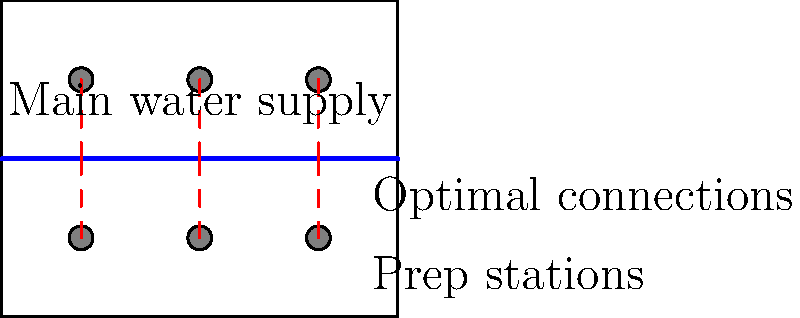As a celebrity chef planning to launch a new product line, you're designing a restaurant kitchen with six preparation stations. Given the layout shown, what is the total length of piping required to connect all stations to the main water supply using the most efficient plumbing layout? To determine the most efficient plumbing layout and calculate the total length of piping required, we'll follow these steps:

1. Identify the positions of the preparation stations:
   - Three stations at y = 2 (lower row)
   - Three stations at y = 6 (upper row)
   - x-coordinates: 2, 5, and 8 for both rows

2. Locate the main water supply line:
   - Runs horizontally at y = 4

3. Calculate the shortest distance from each station to the main supply:
   - For lower row: 4 - 2 = 2 units each
   - For upper row: 6 - 4 = 2 units each

4. Sum up the lengths:
   - 6 stations × 2 units each = 12 units total

5. Convert to appropriate units:
   - Assuming the grid represents meters, the total length is 12 meters

This layout minimizes the total piping length by connecting each station vertically to the centrally located main water supply, avoiding any unnecessary horizontal runs.
Answer: 12 meters 